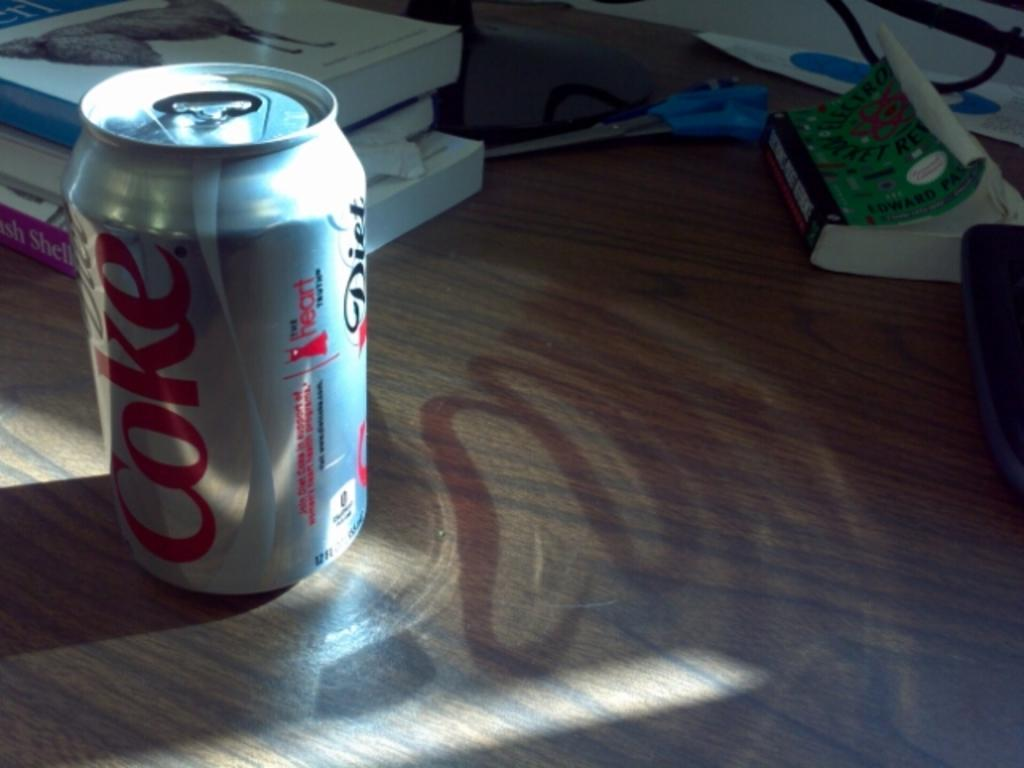Provide a one-sentence caption for the provided image. A single can of Diet Coke on a table with other items. 